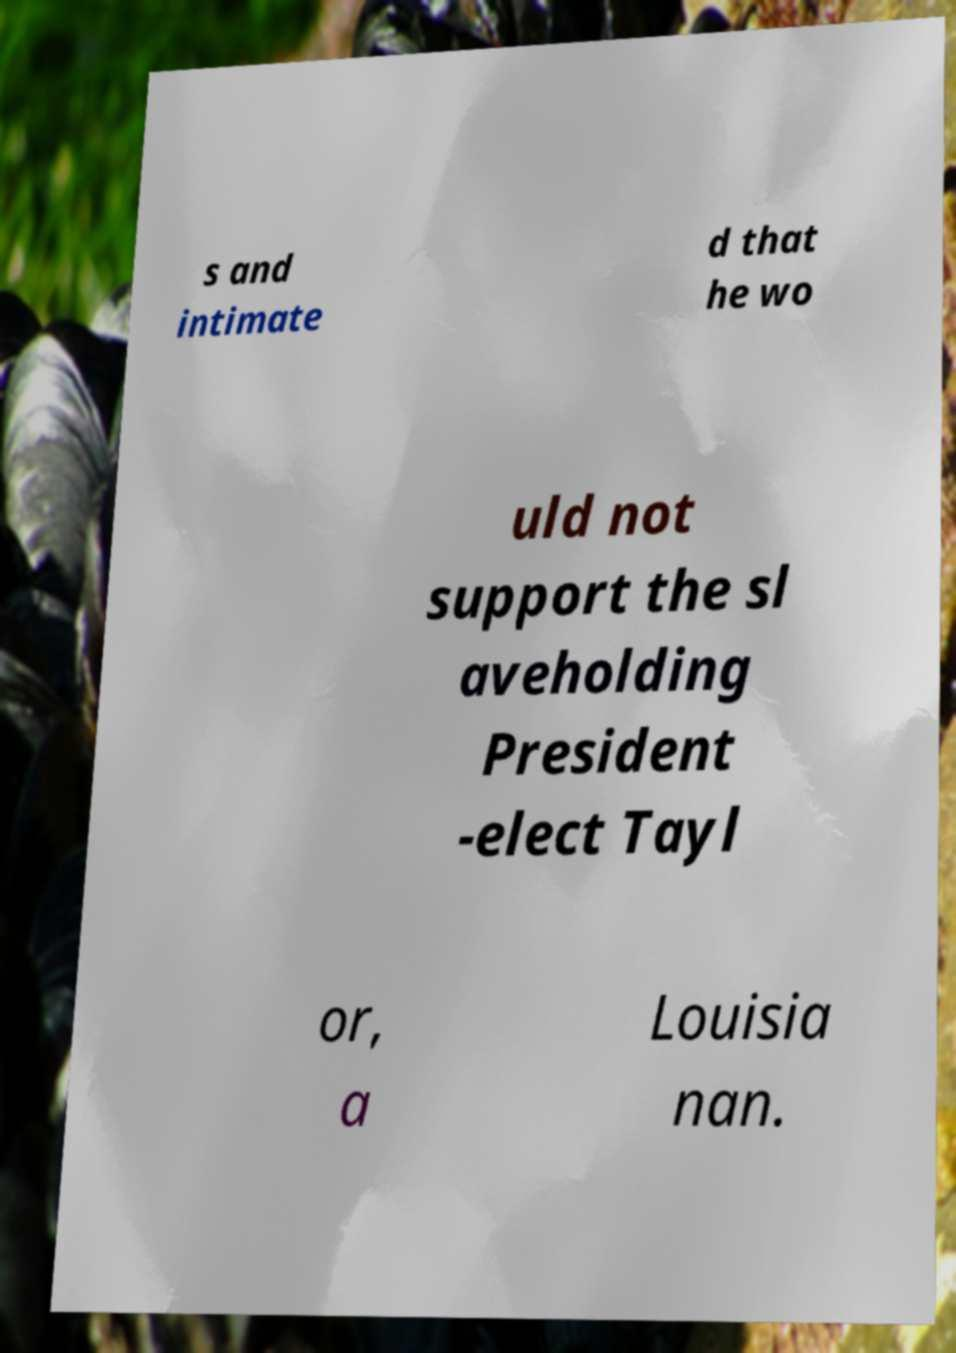Can you accurately transcribe the text from the provided image for me? s and intimate d that he wo uld not support the sl aveholding President -elect Tayl or, a Louisia nan. 